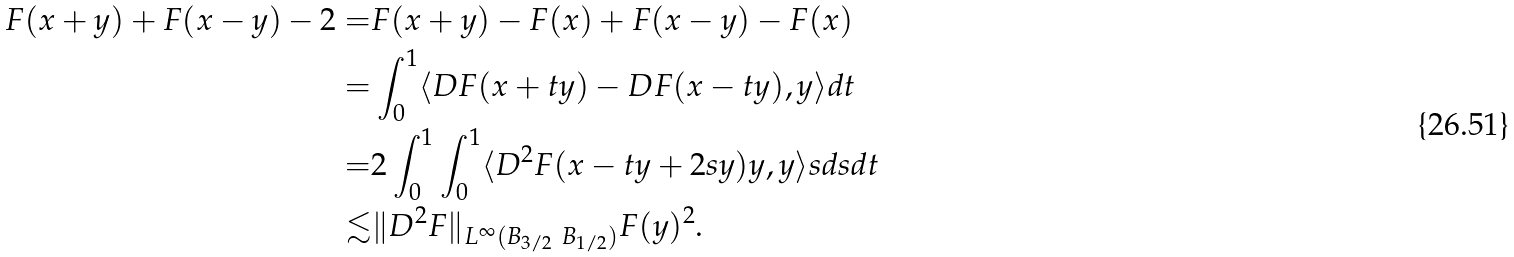<formula> <loc_0><loc_0><loc_500><loc_500>F ( x + y ) + F ( x - y ) - 2 = & F ( x + y ) - F ( x ) + F ( x - y ) - F ( x ) \\ = & \int _ { 0 } ^ { 1 } \langle D F ( x + t y ) - D F ( x - t y ) , y \rangle d t \\ = & 2 \int _ { 0 } ^ { 1 } \int _ { 0 } ^ { 1 } \langle D ^ { 2 } F ( x - t y + 2 s y ) y , y \rangle s d s d t \\ \lesssim & \| D ^ { 2 } F \| _ { L ^ { \infty } ( B _ { 3 / 2 } \ B _ { 1 / 2 } ) } F ( y ) ^ { 2 } .</formula> 